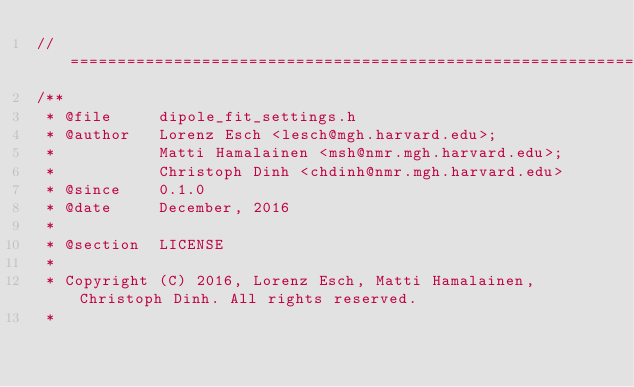<code> <loc_0><loc_0><loc_500><loc_500><_C_>//=============================================================================================================
/**
 * @file     dipole_fit_settings.h
 * @author   Lorenz Esch <lesch@mgh.harvard.edu>;
 *           Matti Hamalainen <msh@nmr.mgh.harvard.edu>;
 *           Christoph Dinh <chdinh@nmr.mgh.harvard.edu>
 * @since    0.1.0
 * @date     December, 2016
 *
 * @section  LICENSE
 *
 * Copyright (C) 2016, Lorenz Esch, Matti Hamalainen, Christoph Dinh. All rights reserved.
 *</code> 